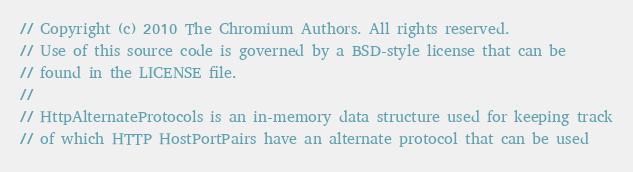<code> <loc_0><loc_0><loc_500><loc_500><_C_>// Copyright (c) 2010 The Chromium Authors. All rights reserved.
// Use of this source code is governed by a BSD-style license that can be
// found in the LICENSE file.
//
// HttpAlternateProtocols is an in-memory data structure used for keeping track
// of which HTTP HostPortPairs have an alternate protocol that can be used</code> 